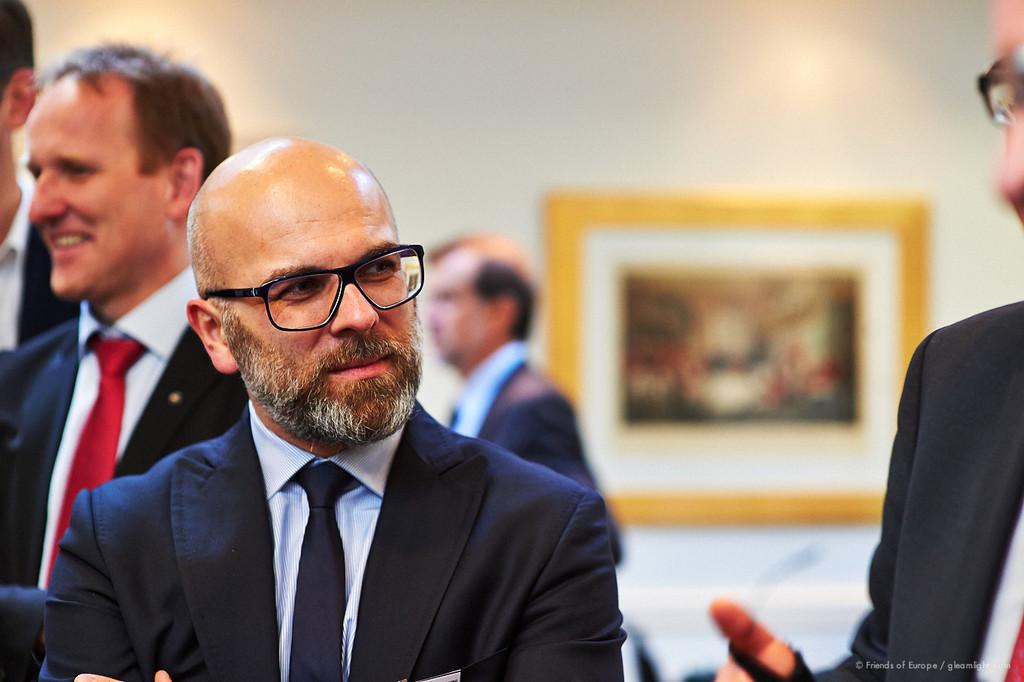What can be seen in the image regarding the people? There are persons wearing clothes in the image. What object is present on the wall in the image? There is a photo frame on the wall in the image. How would you describe the background of the image? The background of the image is blurred. How many horses are present in the image? There are no horses visible in the image. What type of yoke is being used by the persons in the image? There is no yoke present in the image. 